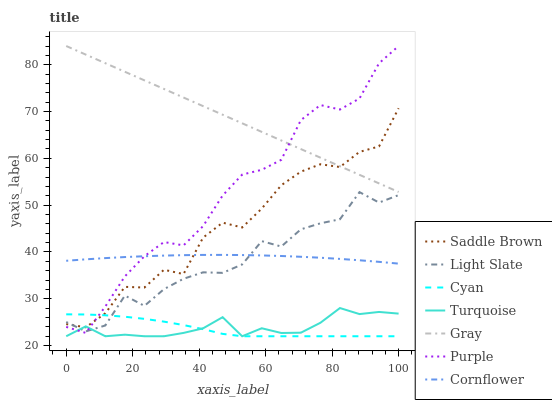Does Cyan have the minimum area under the curve?
Answer yes or no. Yes. Does Gray have the maximum area under the curve?
Answer yes or no. Yes. Does Turquoise have the minimum area under the curve?
Answer yes or no. No. Does Turquoise have the maximum area under the curve?
Answer yes or no. No. Is Gray the smoothest?
Answer yes or no. Yes. Is Saddle Brown the roughest?
Answer yes or no. Yes. Is Turquoise the smoothest?
Answer yes or no. No. Is Turquoise the roughest?
Answer yes or no. No. Does Turquoise have the lowest value?
Answer yes or no. Yes. Does Cornflower have the lowest value?
Answer yes or no. No. Does Purple have the highest value?
Answer yes or no. Yes. Does Turquoise have the highest value?
Answer yes or no. No. Is Light Slate less than Gray?
Answer yes or no. Yes. Is Gray greater than Light Slate?
Answer yes or no. Yes. Does Light Slate intersect Cornflower?
Answer yes or no. Yes. Is Light Slate less than Cornflower?
Answer yes or no. No. Is Light Slate greater than Cornflower?
Answer yes or no. No. Does Light Slate intersect Gray?
Answer yes or no. No. 